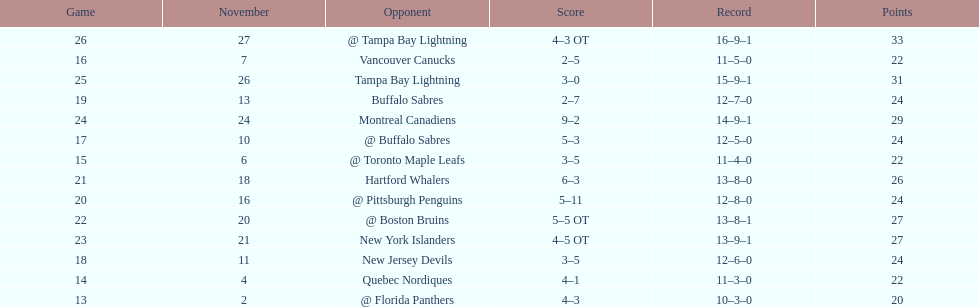Did the tampa bay lightning have the least amount of wins? Yes. 